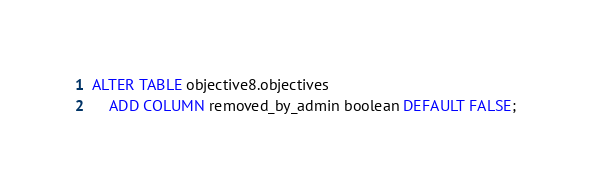<code> <loc_0><loc_0><loc_500><loc_500><_SQL_>ALTER TABLE objective8.objectives 
    ADD COLUMN removed_by_admin boolean DEFAULT FALSE;
</code> 